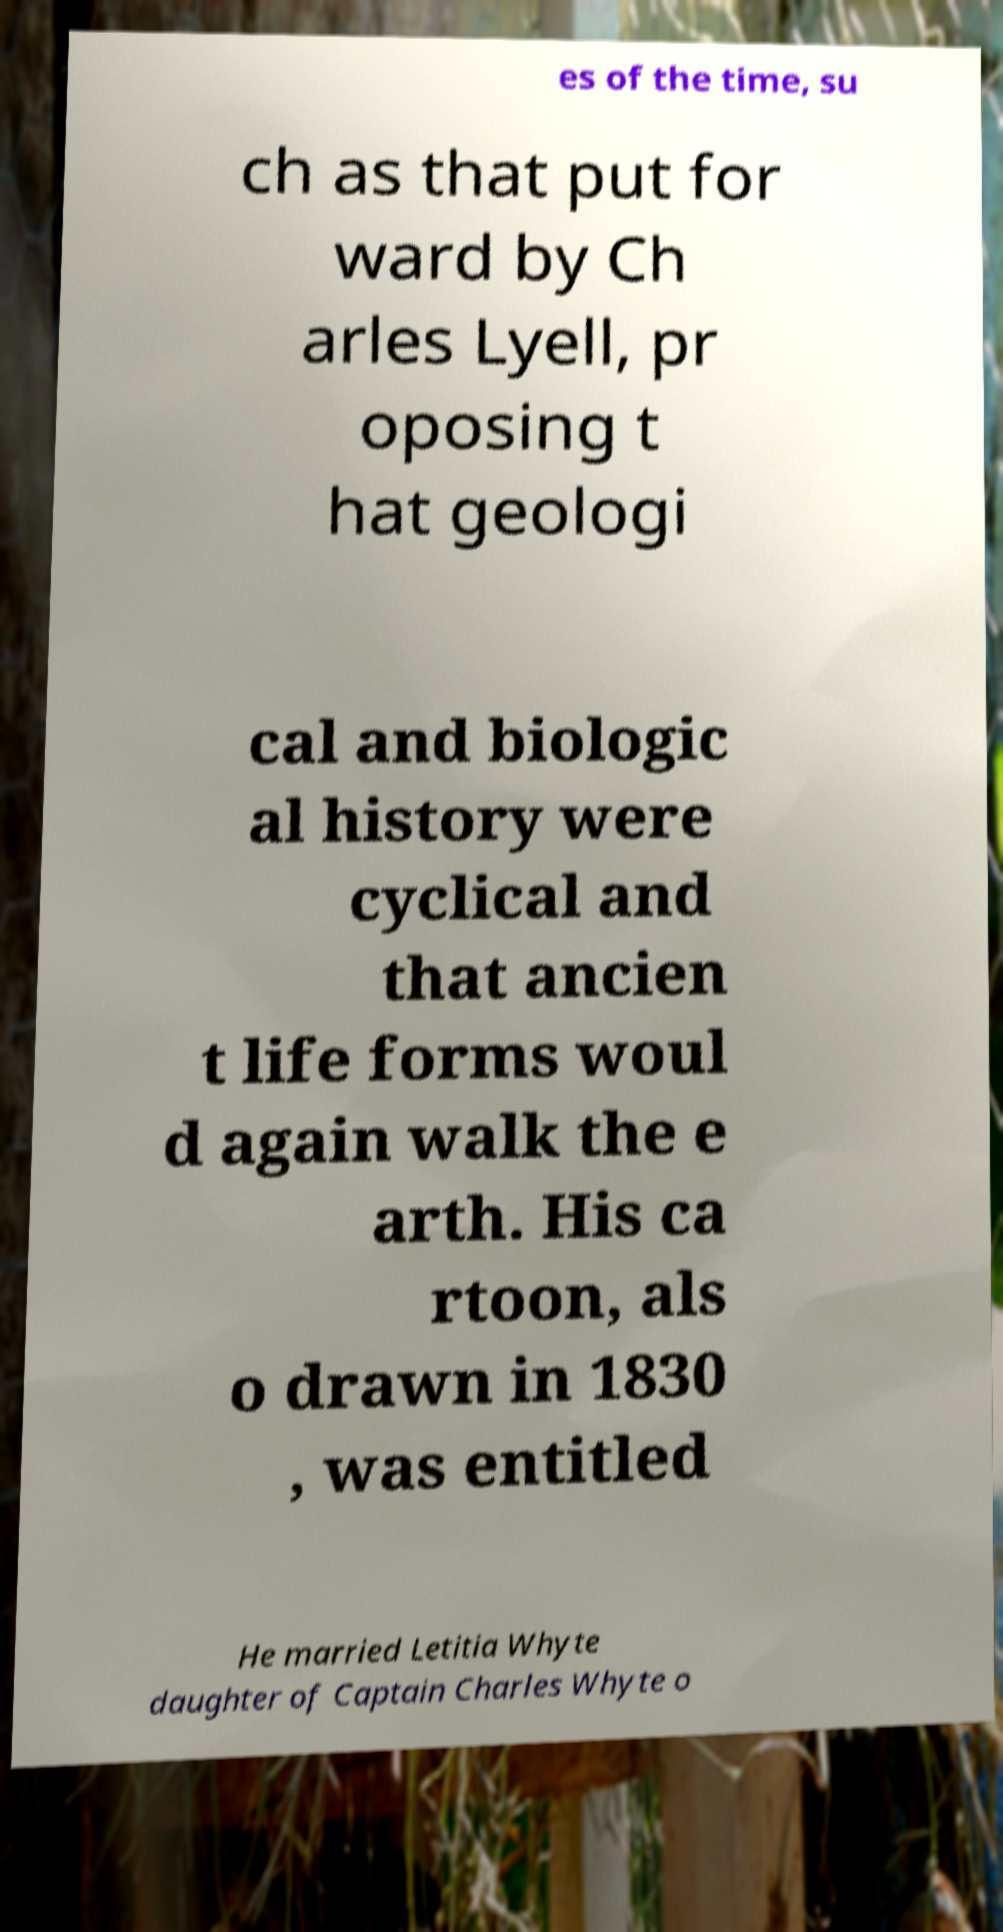Please identify and transcribe the text found in this image. es of the time, su ch as that put for ward by Ch arles Lyell, pr oposing t hat geologi cal and biologic al history were cyclical and that ancien t life forms woul d again walk the e arth. His ca rtoon, als o drawn in 1830 , was entitled He married Letitia Whyte daughter of Captain Charles Whyte o 